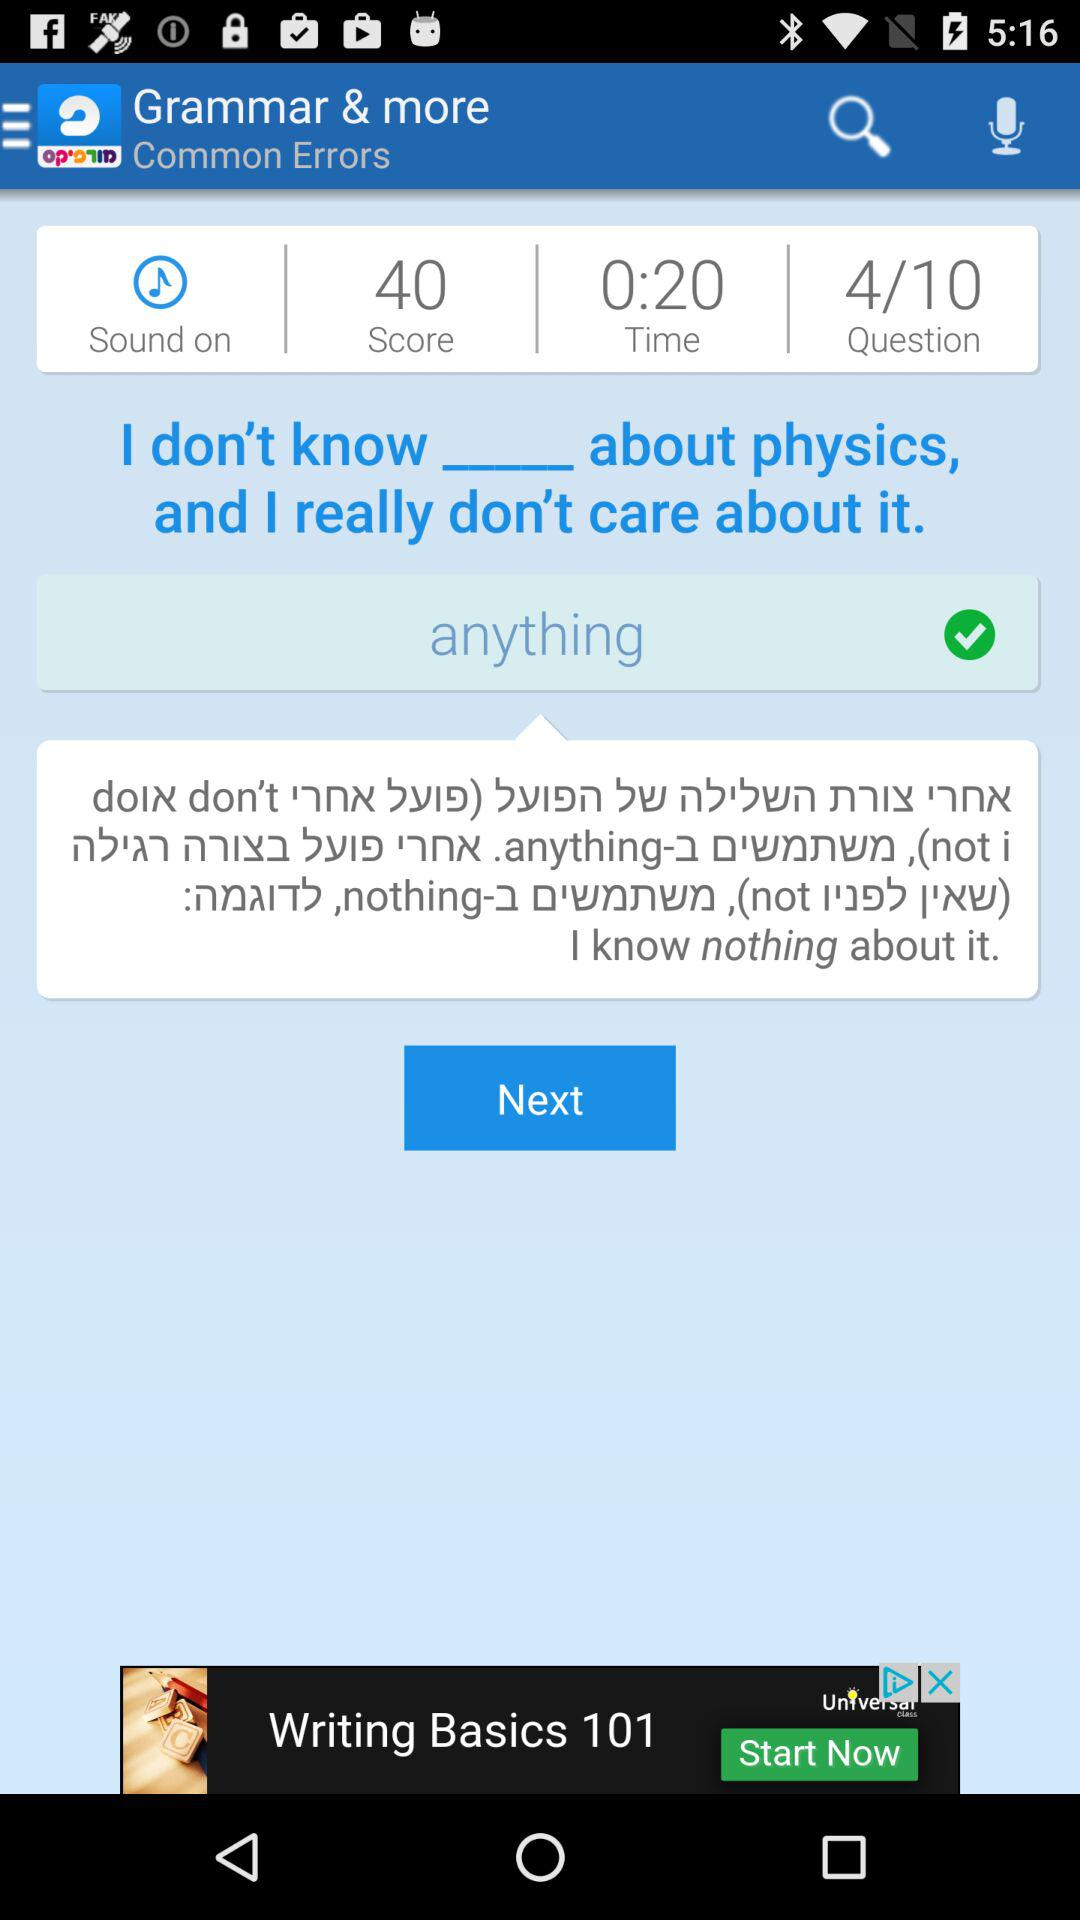What's the total number of questions? The total number of questions is 10. 